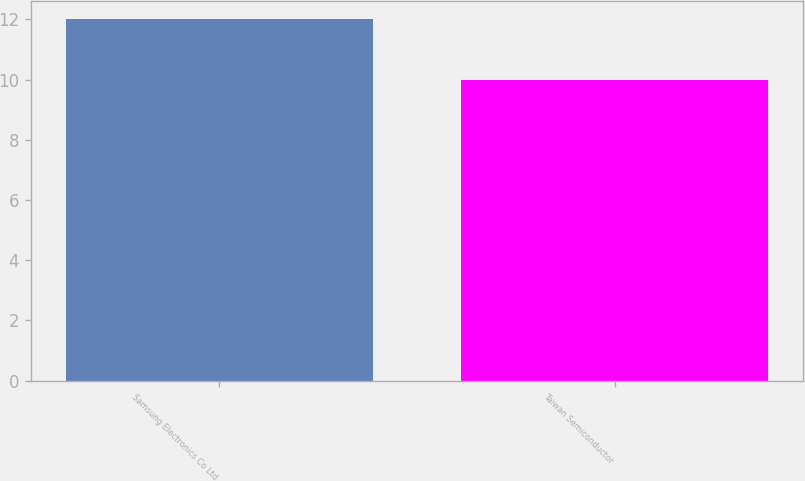Convert chart. <chart><loc_0><loc_0><loc_500><loc_500><bar_chart><fcel>Samsung Electronics Co Ltd<fcel>Taiwan Semiconductor<nl><fcel>12<fcel>10<nl></chart> 